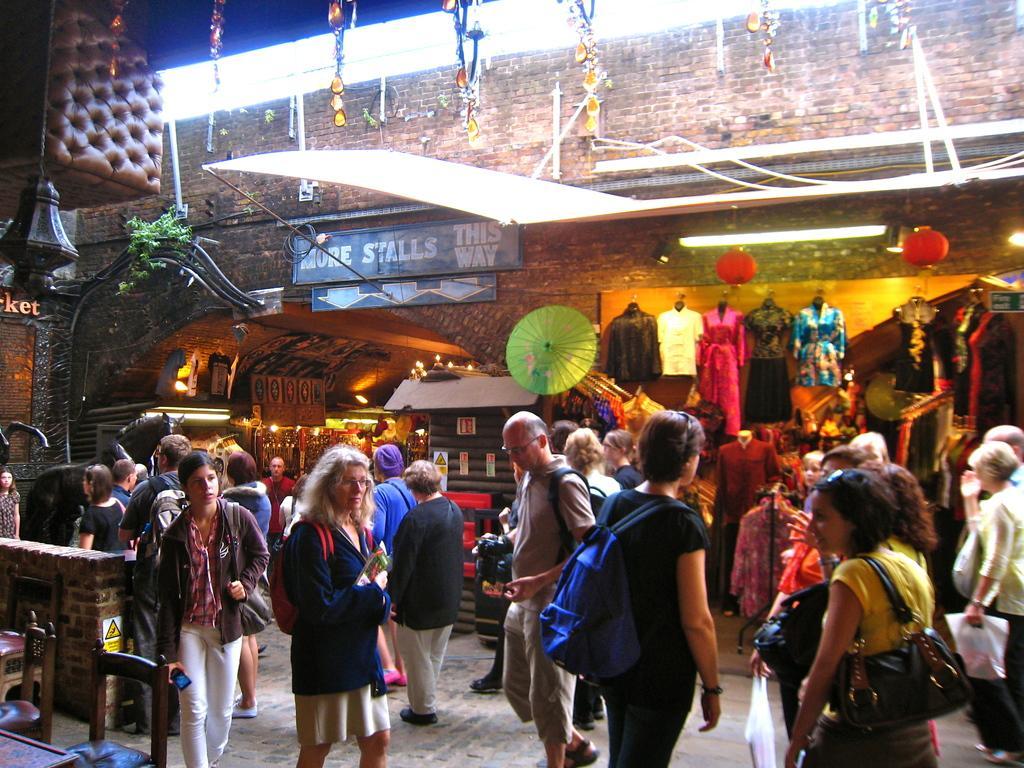In one or two sentences, can you explain what this image depicts? This image consists of many people standing on the road. In the background, there are stalls. And a wall to which many clothes are hanged. At the bottom, there is a floor. 